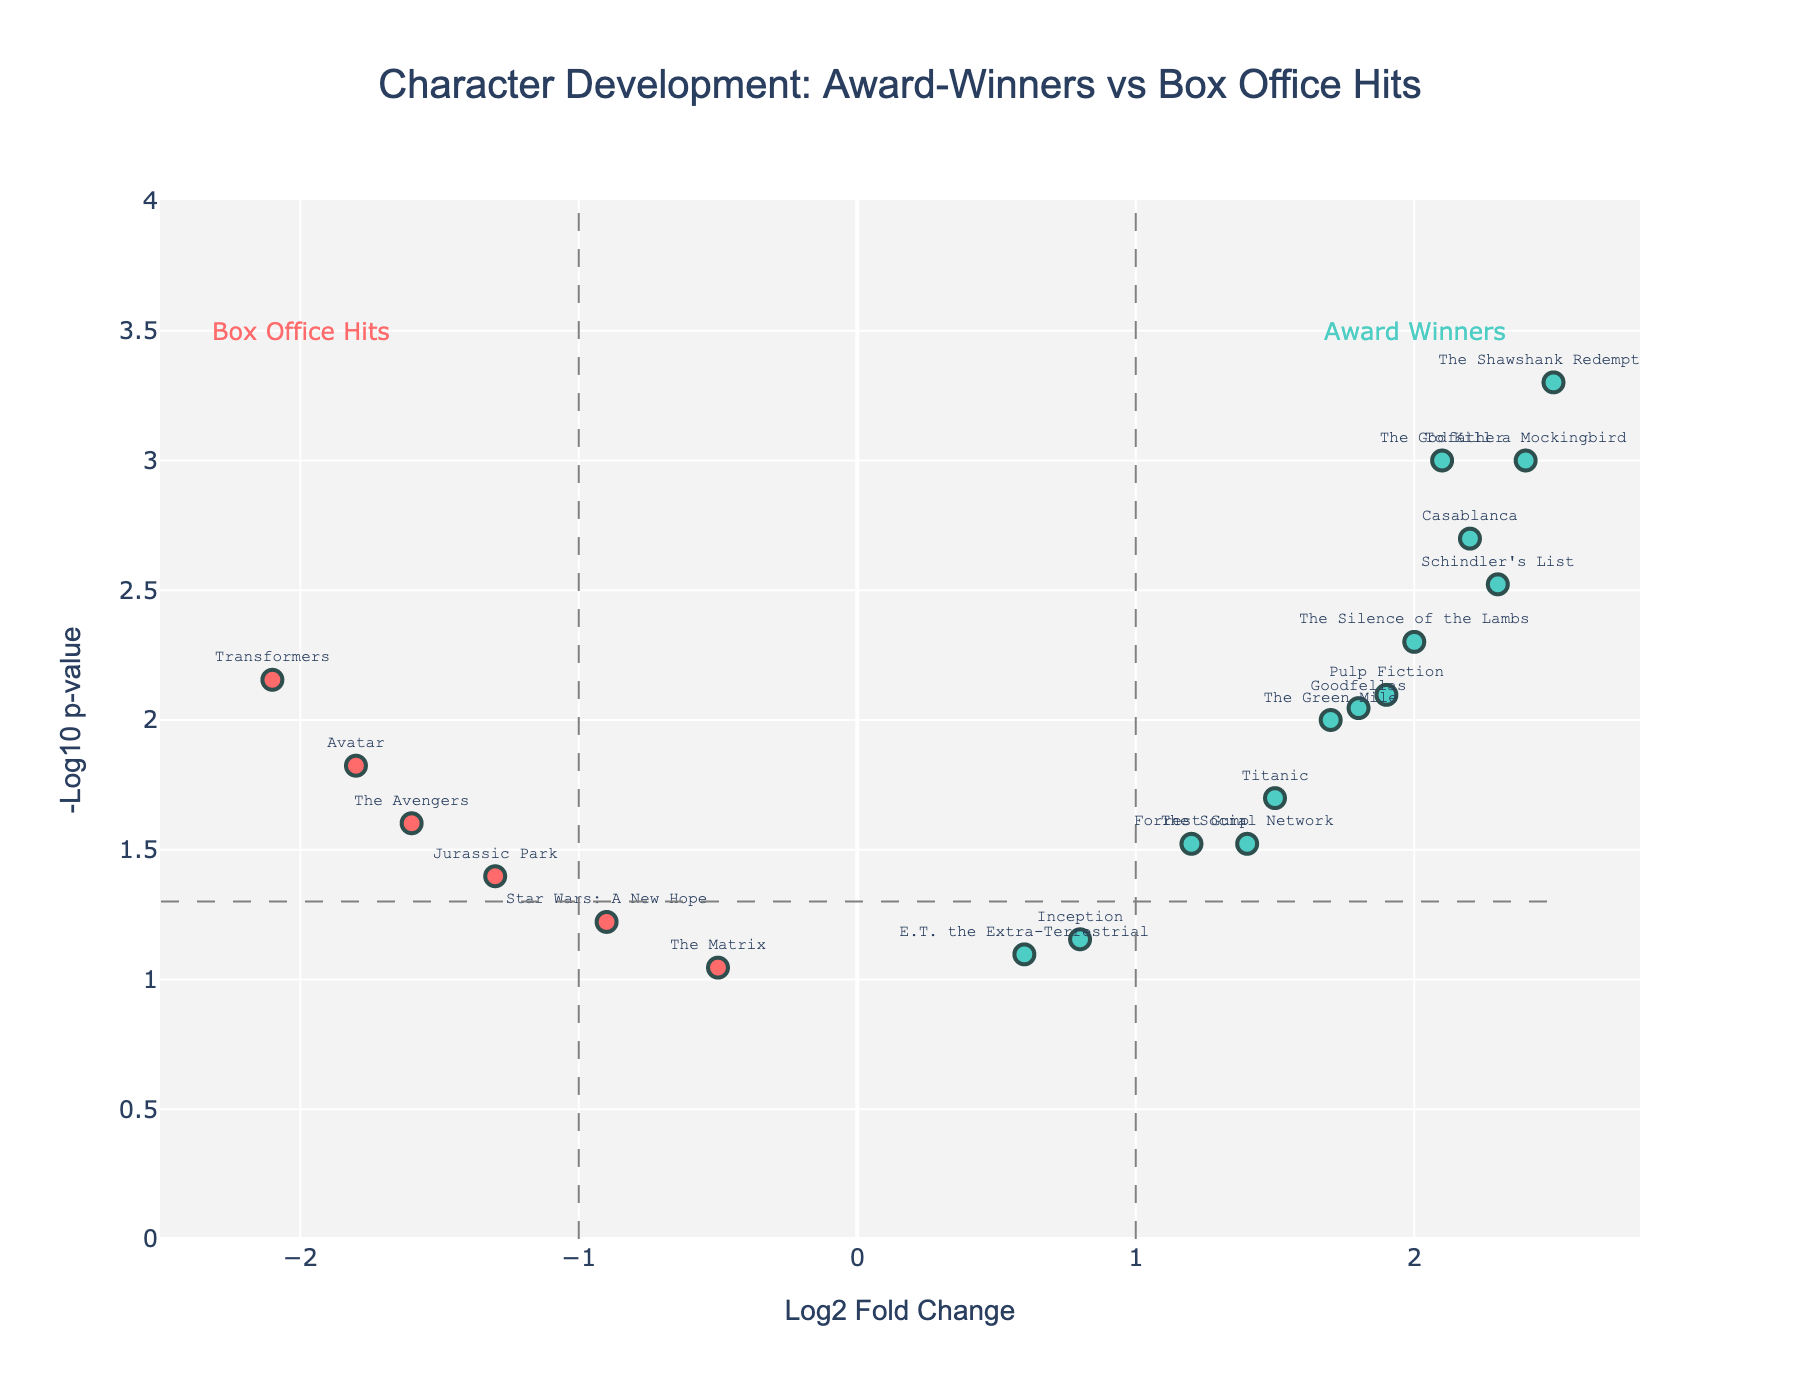What's the title of the plot? The title of the plot is typically positioned at the top of the figure. In this case, it reads: "Character Development: Award-Winners vs Box Office Hits." Therefore, by looking at the top of the plot, we can find the title.
Answer: Character Development: Award-Winners vs Box Office Hits What is the x-axis label? To find the x-axis label, you need to look at the text along the horizontal axis of the plot. In this plot, it is labeled as "Log2 Fold Change."
Answer: Log2 Fold Change Which character has the highest log2 fold change value? To determine this, look for the point furthest to the right on the x-axis. According to the plot, "The Shawshank Redemption" is positioned at the highest value on the x-axis.
Answer: The Shawshank Redemption How many characters have a negative log2 fold change? The characters with negative log2 fold change are those whose points are located to the left of the y-axis. By counting them, you can see "Avatar," "Jurassic Park," "Star Wars: A New Hope," "The Avengers," "The Matrix," and "Transformers" are these characters.
Answer: 6 Which character has the lowest p-value? The lowest p-value is represented by the highest y-value in the plot, as p-values are shown in the negative log scale. "The Shawshank Redemption" appears at the highest y-axis position, indicating the lowest p-value.
Answer: The Shawshank Redemption Between "Avatar" and "Titanic," which character shows higher development depth? Compare the log2 fold change values for both characters. "Titanic" has a positive log2 fold change, while "Avatar" has a negative log2 fold change. Therefore, "Titanic" shows higher development depth.
Answer: Titanic What trend is indicated by the dashed vertical lines at -1 and 1 on the x-axis? The dashed vertical lines at -1 and 1 mark the boundaries where log2 fold changes of characters indicate significant and notable changes. Characters outside these lines show stronger changes, either positive or negative.
Answer: Significant changes boundary Which character's position indicates it was least developed in award-winning screenplays? The least development in award-winning screenplays corresponds to the character furthest to the left with the smallest log2 fold change and significant p-value. According to the plot, "Transformers" is the least developed as it is the farthest left with a very low log2 fold change and significant p-value.
Answer: Transformers 